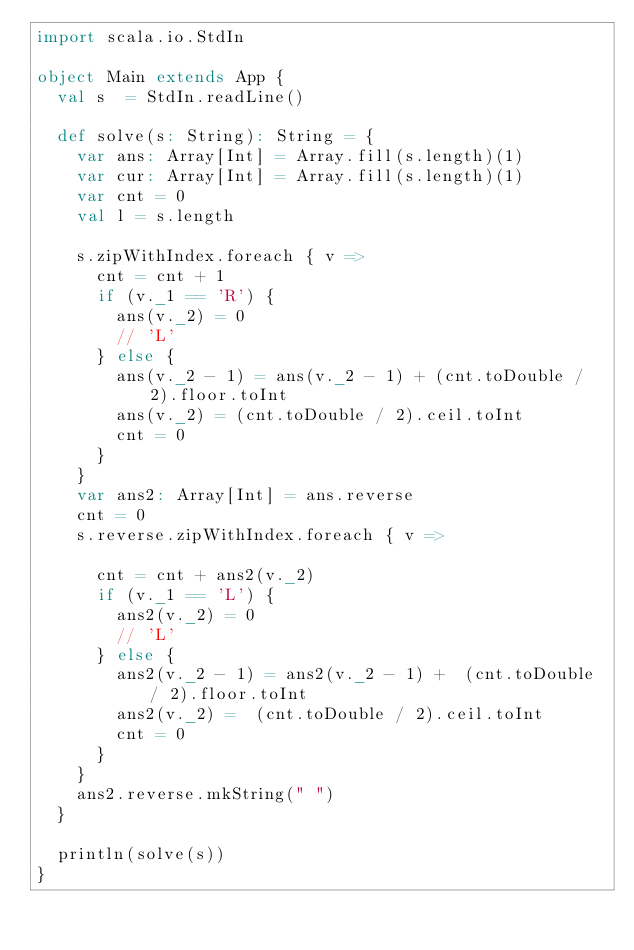<code> <loc_0><loc_0><loc_500><loc_500><_Scala_>import scala.io.StdIn

object Main extends App {
  val s  = StdIn.readLine()

  def solve(s: String): String = {
    var ans: Array[Int] = Array.fill(s.length)(1)
    var cur: Array[Int] = Array.fill(s.length)(1)    
    var cnt = 0
    val l = s.length

    s.zipWithIndex.foreach { v =>
      cnt = cnt + 1
      if (v._1 == 'R') {
        ans(v._2) = 0
        // 'L'
      } else {
        ans(v._2 - 1) = ans(v._2 - 1) + (cnt.toDouble / 2).floor.toInt
        ans(v._2) = (cnt.toDouble / 2).ceil.toInt
        cnt = 0
      }
    }
    var ans2: Array[Int] = ans.reverse
    cnt = 0
    s.reverse.zipWithIndex.foreach { v =>

      cnt = cnt + ans2(v._2)
      if (v._1 == 'L') {
        ans2(v._2) = 0
        // 'L'
      } else {
        ans2(v._2 - 1) = ans2(v._2 - 1) +  (cnt.toDouble / 2).floor.toInt
        ans2(v._2) =  (cnt.toDouble / 2).ceil.toInt
        cnt = 0
      }
    }
    ans2.reverse.mkString(" ")
  }
  
  println(solve(s))  
}
  

</code> 